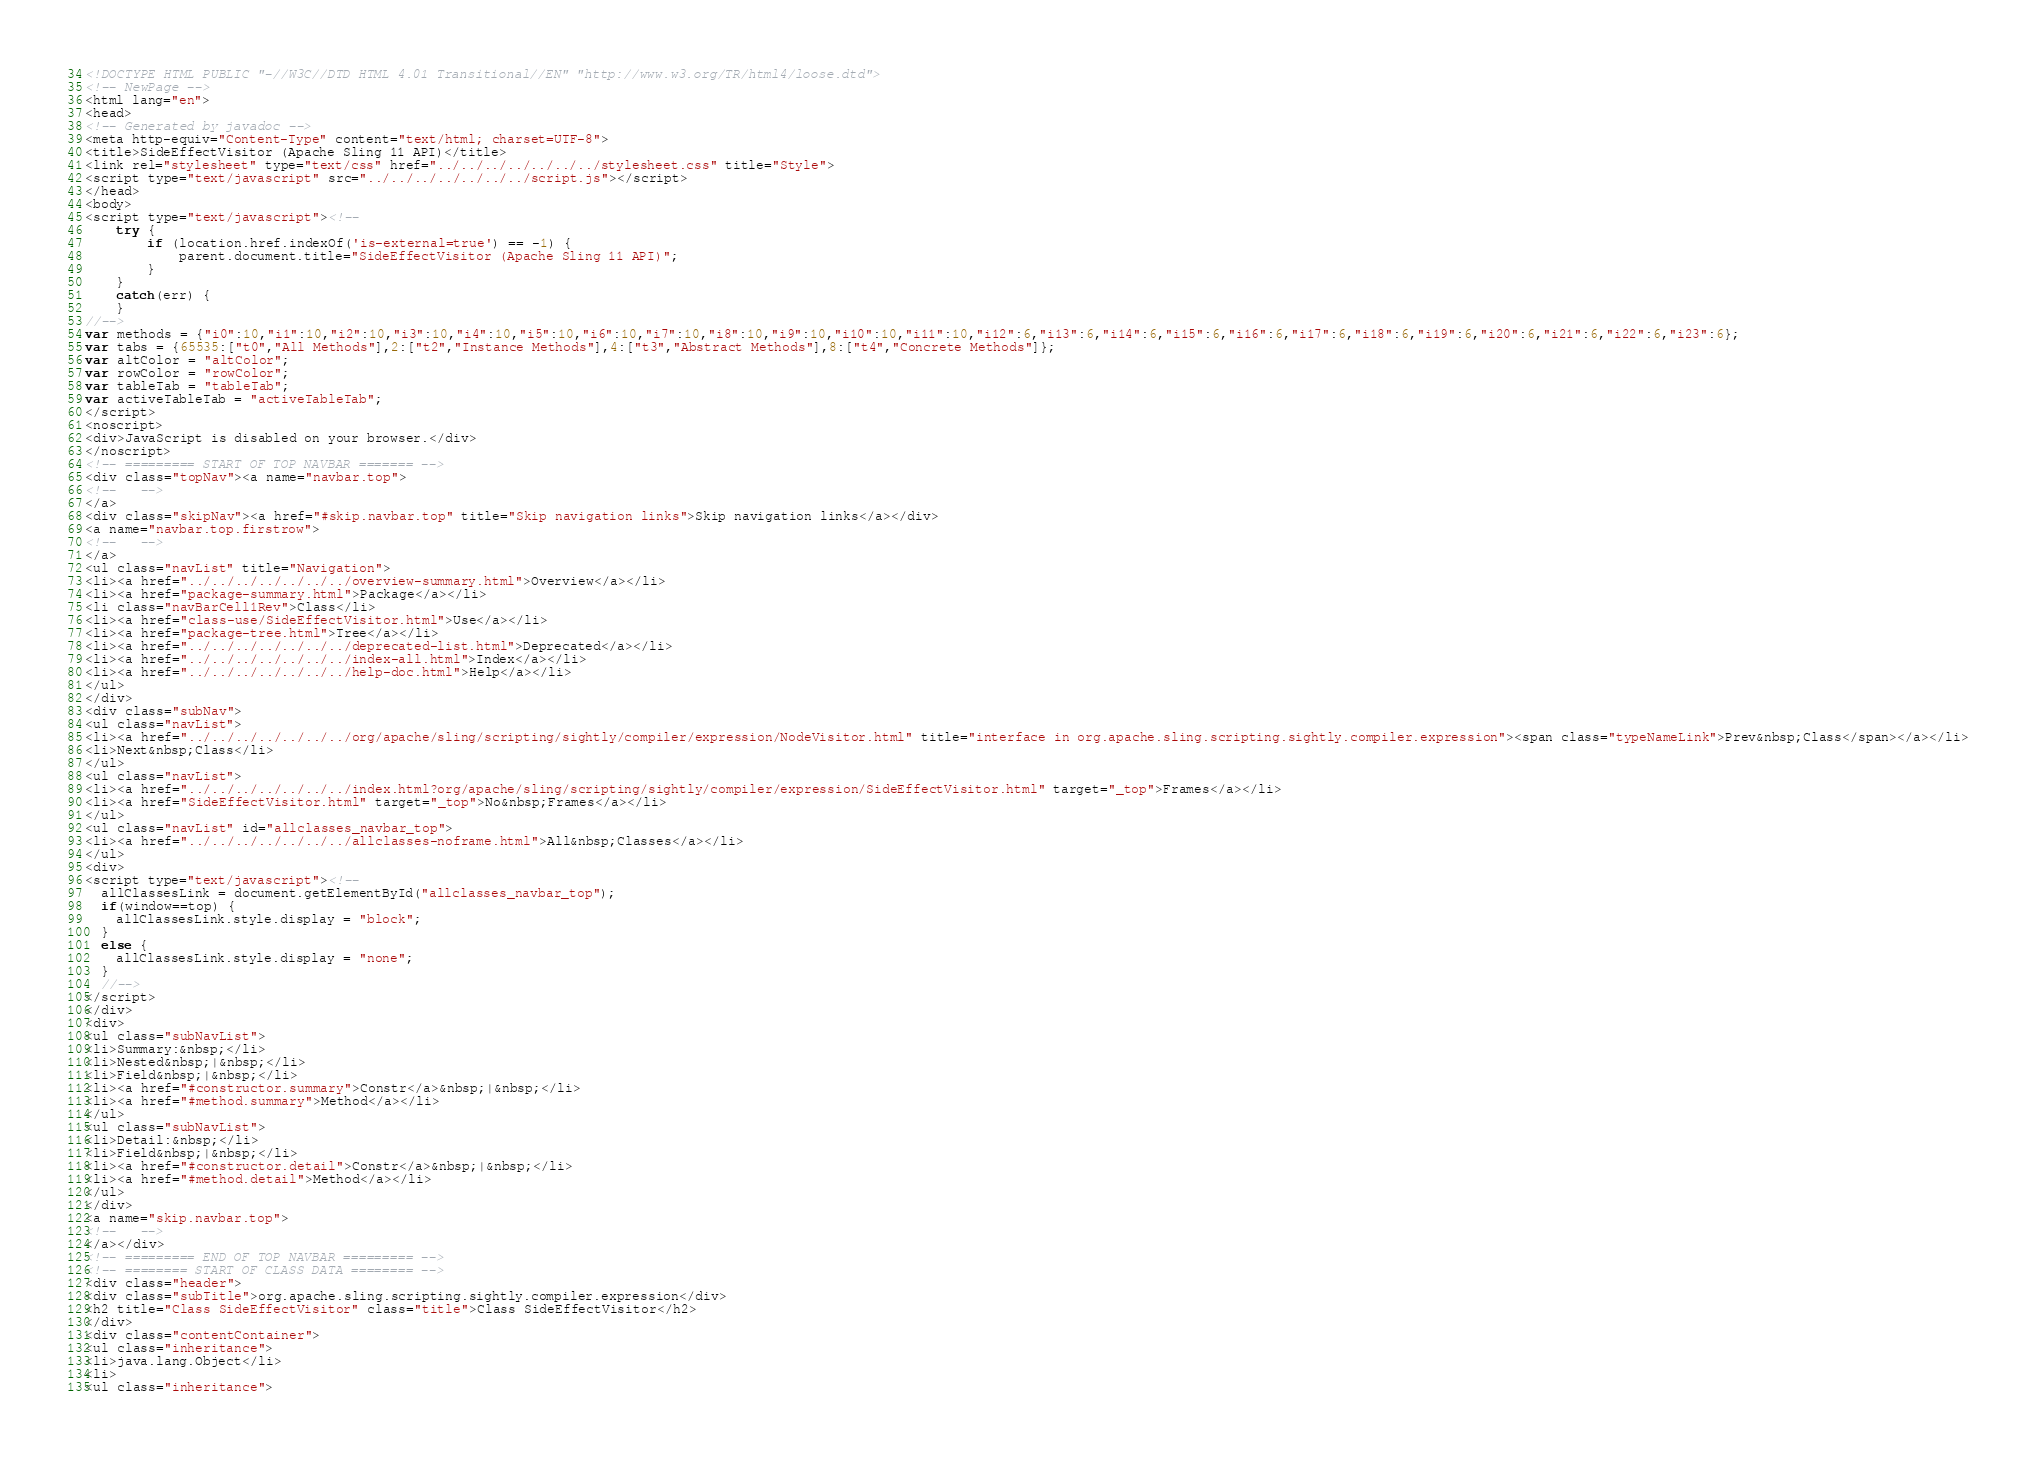<code> <loc_0><loc_0><loc_500><loc_500><_HTML_><!DOCTYPE HTML PUBLIC "-//W3C//DTD HTML 4.01 Transitional//EN" "http://www.w3.org/TR/html4/loose.dtd">
<!-- NewPage -->
<html lang="en">
<head>
<!-- Generated by javadoc -->
<meta http-equiv="Content-Type" content="text/html; charset=UTF-8">
<title>SideEffectVisitor (Apache Sling 11 API)</title>
<link rel="stylesheet" type="text/css" href="../../../../../../../stylesheet.css" title="Style">
<script type="text/javascript" src="../../../../../../../script.js"></script>
</head>
<body>
<script type="text/javascript"><!--
    try {
        if (location.href.indexOf('is-external=true') == -1) {
            parent.document.title="SideEffectVisitor (Apache Sling 11 API)";
        }
    }
    catch(err) {
    }
//-->
var methods = {"i0":10,"i1":10,"i2":10,"i3":10,"i4":10,"i5":10,"i6":10,"i7":10,"i8":10,"i9":10,"i10":10,"i11":10,"i12":6,"i13":6,"i14":6,"i15":6,"i16":6,"i17":6,"i18":6,"i19":6,"i20":6,"i21":6,"i22":6,"i23":6};
var tabs = {65535:["t0","All Methods"],2:["t2","Instance Methods"],4:["t3","Abstract Methods"],8:["t4","Concrete Methods"]};
var altColor = "altColor";
var rowColor = "rowColor";
var tableTab = "tableTab";
var activeTableTab = "activeTableTab";
</script>
<noscript>
<div>JavaScript is disabled on your browser.</div>
</noscript>
<!-- ========= START OF TOP NAVBAR ======= -->
<div class="topNav"><a name="navbar.top">
<!--   -->
</a>
<div class="skipNav"><a href="#skip.navbar.top" title="Skip navigation links">Skip navigation links</a></div>
<a name="navbar.top.firstrow">
<!--   -->
</a>
<ul class="navList" title="Navigation">
<li><a href="../../../../../../../overview-summary.html">Overview</a></li>
<li><a href="package-summary.html">Package</a></li>
<li class="navBarCell1Rev">Class</li>
<li><a href="class-use/SideEffectVisitor.html">Use</a></li>
<li><a href="package-tree.html">Tree</a></li>
<li><a href="../../../../../../../deprecated-list.html">Deprecated</a></li>
<li><a href="../../../../../../../index-all.html">Index</a></li>
<li><a href="../../../../../../../help-doc.html">Help</a></li>
</ul>
</div>
<div class="subNav">
<ul class="navList">
<li><a href="../../../../../../../org/apache/sling/scripting/sightly/compiler/expression/NodeVisitor.html" title="interface in org.apache.sling.scripting.sightly.compiler.expression"><span class="typeNameLink">Prev&nbsp;Class</span></a></li>
<li>Next&nbsp;Class</li>
</ul>
<ul class="navList">
<li><a href="../../../../../../../index.html?org/apache/sling/scripting/sightly/compiler/expression/SideEffectVisitor.html" target="_top">Frames</a></li>
<li><a href="SideEffectVisitor.html" target="_top">No&nbsp;Frames</a></li>
</ul>
<ul class="navList" id="allclasses_navbar_top">
<li><a href="../../../../../../../allclasses-noframe.html">All&nbsp;Classes</a></li>
</ul>
<div>
<script type="text/javascript"><!--
  allClassesLink = document.getElementById("allclasses_navbar_top");
  if(window==top) {
    allClassesLink.style.display = "block";
  }
  else {
    allClassesLink.style.display = "none";
  }
  //-->
</script>
</div>
<div>
<ul class="subNavList">
<li>Summary:&nbsp;</li>
<li>Nested&nbsp;|&nbsp;</li>
<li>Field&nbsp;|&nbsp;</li>
<li><a href="#constructor.summary">Constr</a>&nbsp;|&nbsp;</li>
<li><a href="#method.summary">Method</a></li>
</ul>
<ul class="subNavList">
<li>Detail:&nbsp;</li>
<li>Field&nbsp;|&nbsp;</li>
<li><a href="#constructor.detail">Constr</a>&nbsp;|&nbsp;</li>
<li><a href="#method.detail">Method</a></li>
</ul>
</div>
<a name="skip.navbar.top">
<!--   -->
</a></div>
<!-- ========= END OF TOP NAVBAR ========= -->
<!-- ======== START OF CLASS DATA ======== -->
<div class="header">
<div class="subTitle">org.apache.sling.scripting.sightly.compiler.expression</div>
<h2 title="Class SideEffectVisitor" class="title">Class SideEffectVisitor</h2>
</div>
<div class="contentContainer">
<ul class="inheritance">
<li>java.lang.Object</li>
<li>
<ul class="inheritance"></code> 